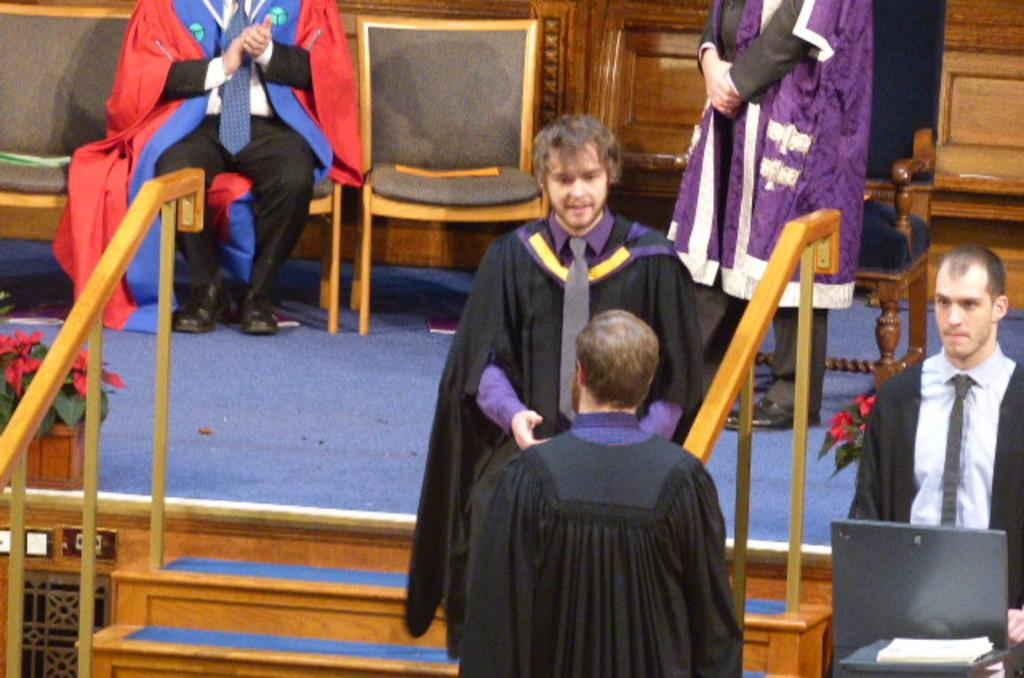How many people are in the image? There is a group of people in the image. What are some of the people in the image doing? Some people are standing, while a man is seated on a chair. What can be seen in front of the seated man? There are flowers and plants in front of the seated man. How many light bulbs are hanging above the group of people in the image? There is no mention of light bulbs in the provided facts, so we cannot determine their presence or quantity in the image. 